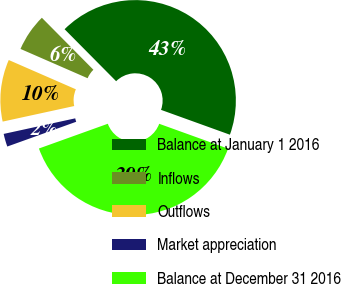Convert chart to OTSL. <chart><loc_0><loc_0><loc_500><loc_500><pie_chart><fcel>Balance at January 1 2016<fcel>Inflows<fcel>Outflows<fcel>Market appreciation<fcel>Balance at December 31 2016<nl><fcel>42.94%<fcel>6.02%<fcel>9.96%<fcel>2.08%<fcel>39.0%<nl></chart> 